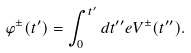Convert formula to latex. <formula><loc_0><loc_0><loc_500><loc_500>\varphi ^ { \pm } ( t ^ { \prime } ) = \int _ { 0 } ^ { t ^ { \prime } } d t ^ { \prime \prime } e V ^ { \pm } ( t ^ { \prime \prime } ) .</formula> 